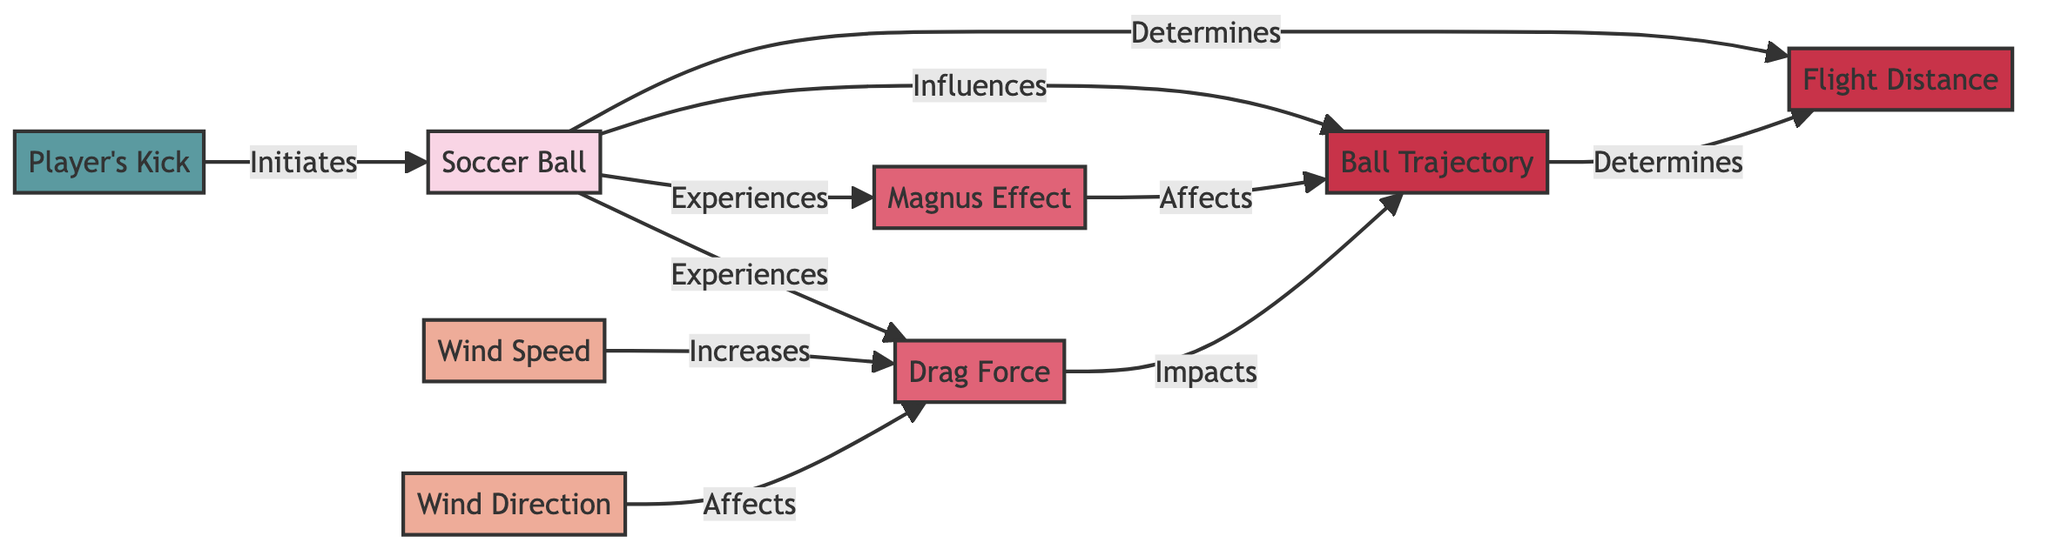What are the two main variables affecting a soccer ball's flight? The diagram indicates that "Wind Speed" and "Wind Direction" are the two main variables that influence the soccer ball's flight, as they are positioned as variables linked directly to the soccer ball.
Answer: Wind Speed, Wind Direction What action initiates the aerodynamics process of the soccer ball? According to the diagram, the action that initiates the aerodynamics process is "Player's Kick," which is represented as pointing to the soccer ball entity.
Answer: Player's Kick How does wind direction affect drag force? The diagram shows an arrow from "Wind Direction" pointing to "Drag Force," indicating that changes in wind direction have an impact on the drag force experienced by the soccer ball.
Answer: Affects What is the relationship between drag force and ball trajectory? The diagram illustrates a direct relationship where "Drag Force" impacts "Ball Trajectory," indicating that changes in drag force influence how the ball travels in the air.
Answer: Impacts How many outcomes are identified in the diagram? The diagram shows two outcomes: "Ball Trajectory" and "Flight Distance." Counting these nodes gives us a total of two outcomes in the diagram.
Answer: 2 What effect does wind speed have on drag force? The diagram indicates an increase in drag force with an increase in wind speed, demonstrating a direct influence of wind speed on the drag force experienced by the soccer ball.
Answer: Increases What determines the flight distance of the soccer ball? The diagram indicates that "Ball Trajectory" determines "Flight Distance," meaning the path taken by the ball influences how far it travels.
Answer: Determines Which factor directly affects the ball's trajectory aside from the drag force? The diagram shows that "Magnus Effect" also affects "Ball Trajectory," in addition to drag force, indicating its importance in the ball's flight behavior.
Answer: Affects What initiates the series of events affecting the soccer ball's aerodynamics? The diagram suggests that the series of events related to the aerodynamics of the soccer ball is initiated by "Player's Kick," which is the starting point for the analysis.
Answer: Player's Kick 